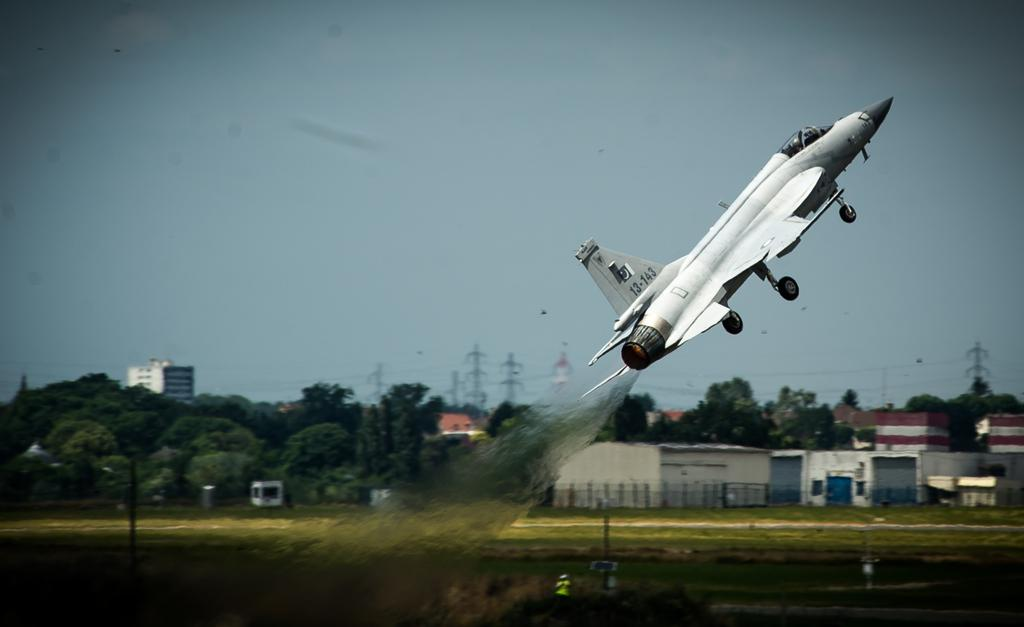<image>
Present a compact description of the photo's key features. A fighter jet is taking off with the tail number 13-143. 